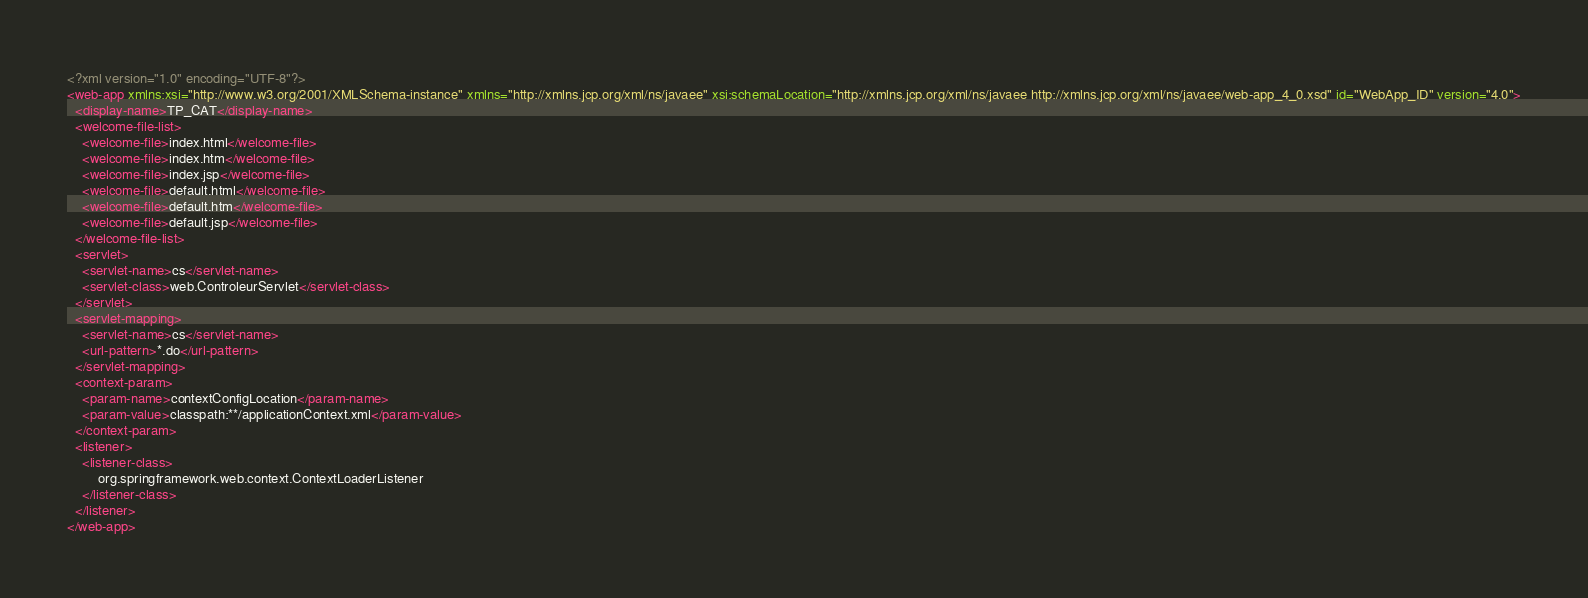<code> <loc_0><loc_0><loc_500><loc_500><_XML_><?xml version="1.0" encoding="UTF-8"?>
<web-app xmlns:xsi="http://www.w3.org/2001/XMLSchema-instance" xmlns="http://xmlns.jcp.org/xml/ns/javaee" xsi:schemaLocation="http://xmlns.jcp.org/xml/ns/javaee http://xmlns.jcp.org/xml/ns/javaee/web-app_4_0.xsd" id="WebApp_ID" version="4.0">
  <display-name>TP_CAT</display-name>
  <welcome-file-list>
    <welcome-file>index.html</welcome-file>
    <welcome-file>index.htm</welcome-file>
    <welcome-file>index.jsp</welcome-file>
    <welcome-file>default.html</welcome-file>
    <welcome-file>default.htm</welcome-file>
    <welcome-file>default.jsp</welcome-file>
  </welcome-file-list>
  <servlet>
  	<servlet-name>cs</servlet-name>
  	<servlet-class>web.ControleurServlet</servlet-class>
  </servlet>
  <servlet-mapping>
  	<servlet-name>cs</servlet-name>
  	<url-pattern>*.do</url-pattern>
  </servlet-mapping>
  <context-param>
  	<param-name>contextConfigLocation</param-name>
  	<param-value>classpath:**/applicationContext.xml</param-value>
  </context-param>
  <listener>
  	<listener-class>
  		org.springframework.web.context.ContextLoaderListener
  	</listener-class>
  </listener>
</web-app></code> 